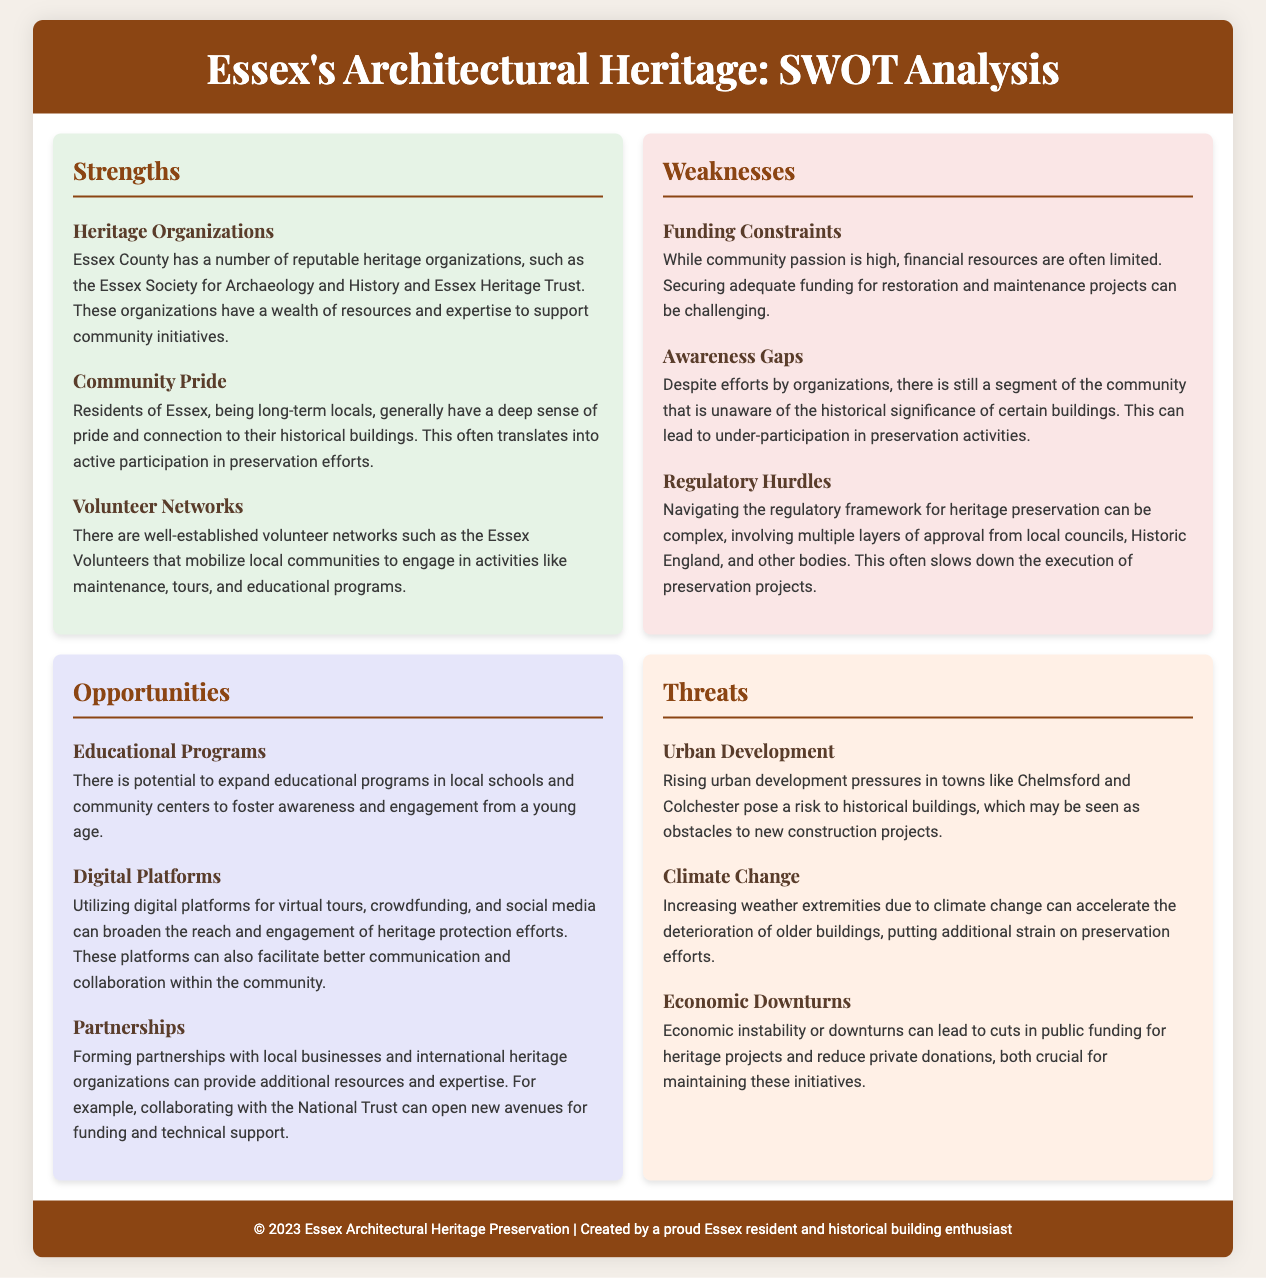What are two heritage organizations mentioned? The document lists two organizations: the Essex Society for Archaeology and History and Essex Heritage Trust.
Answer: Essex Society for Archaeology and History, Essex Heritage Trust What is a strength related to community engagement? One of the strengths mentioned is community pride and connection to historical buildings which translates into active participation in preservation efforts.
Answer: Community pride What is one weakness listed regarding community participation? The document mentions funding constraints as a significant challenge in securing adequate resources for preservation work.
Answer: Funding constraints Which opportunity could broaden engagement efforts? The document highlights the potential of utilizing digital platforms for virtual tours and social media to enhance community engagement.
Answer: Digital platforms What is one threat posed by urban development? The document indicates that rising urban development pressures in towns like Chelmsford and Colchester pose risks to historical buildings.
Answer: Urban development How many strengths are listed in the SWOT analysis? The document details three strengths under the Strengths section.
Answer: Three Name one type of educational opportunity mentioned. The analysis refers to expanding educational programs in local schools and community centers to foster awareness.
Answer: Educational programs What is a potential partnership mentioned in the opportunities? The document suggests forming partnerships with local businesses and international heritage organizations, specifically naming collaboration with the National Trust.
Answer: National Trust 